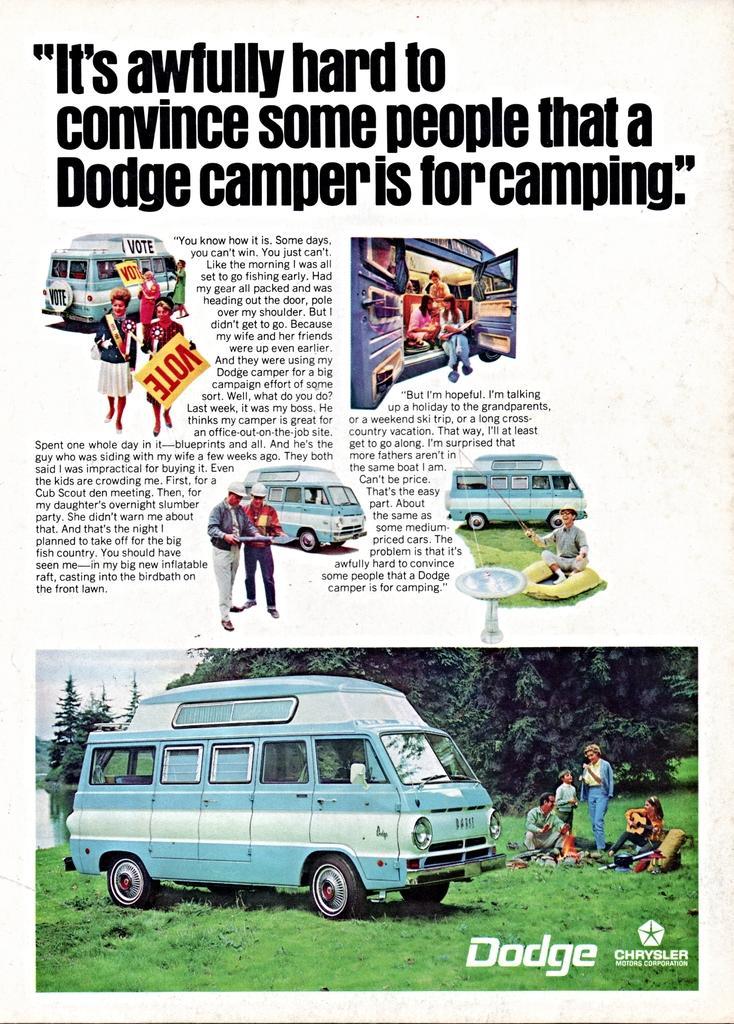Can you describe this image briefly? This is a newspaper. In this image we can see trucks, some persons, boards, trees, grass, some text are there. 